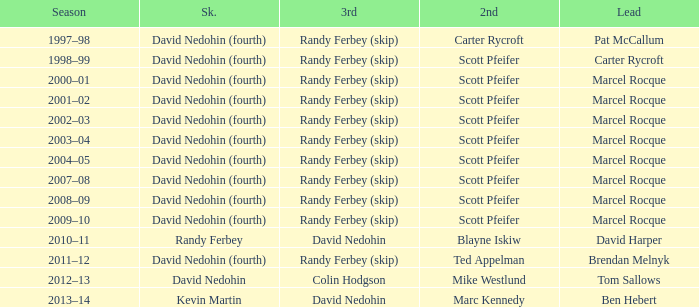Which Third has a Second of scott pfeifer? Randy Ferbey (skip), Randy Ferbey (skip), Randy Ferbey (skip), Randy Ferbey (skip), Randy Ferbey (skip), Randy Ferbey (skip), Randy Ferbey (skip), Randy Ferbey (skip), Randy Ferbey (skip). 